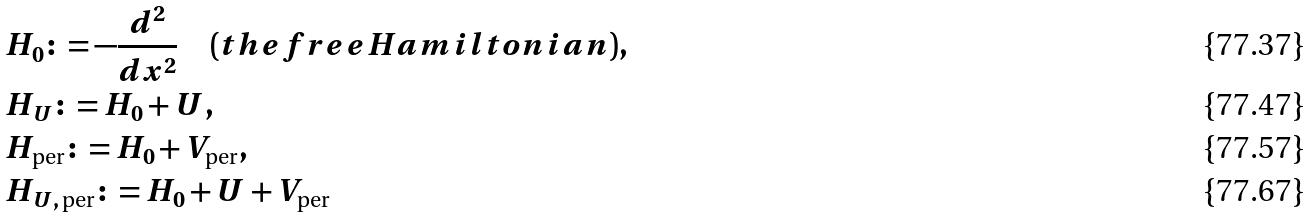Convert formula to latex. <formula><loc_0><loc_0><loc_500><loc_500>& H _ { 0 } \colon = - \frac { d ^ { 2 } } { d x ^ { 2 } } \quad ( t h e f r e e H a m i l t o n i a n ) , \\ & H _ { U } \colon = H _ { 0 } + U , \\ & H _ { \text {per} } \colon = H _ { 0 } + V _ { \text {per} } , \\ & H _ { U , \, \text {per} } \colon = H _ { 0 } + U + V _ { \text {per} }</formula> 